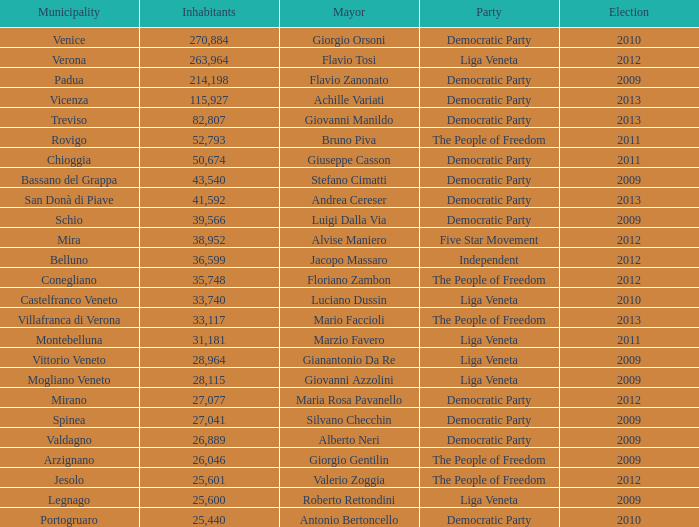How many elections had a population exceeding 36,599 when mayor was giovanni manildo? 1.0. 